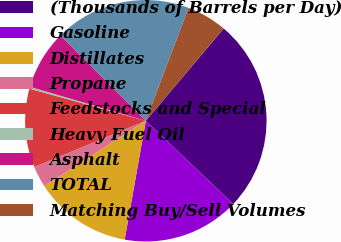Convert chart. <chart><loc_0><loc_0><loc_500><loc_500><pie_chart><fcel>(Thousands of Barrels per Day)<fcel>Gasoline<fcel>Distillates<fcel>Propane<fcel>Feedstocks and Special<fcel>Heavy Fuel Oil<fcel>Asphalt<fcel>TOTAL<fcel>Matching Buy/Sell Volumes<nl><fcel>25.96%<fcel>15.68%<fcel>13.11%<fcel>2.83%<fcel>10.54%<fcel>0.26%<fcel>7.97%<fcel>18.25%<fcel>5.4%<nl></chart> 